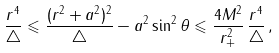<formula> <loc_0><loc_0><loc_500><loc_500>\frac { r ^ { 4 } } { \triangle } \leqslant \frac { ( r ^ { 2 } + a ^ { 2 } ) ^ { 2 } } { \triangle } - a ^ { 2 } \sin ^ { 2 } \theta \leqslant \frac { 4 M ^ { 2 } } { r _ { + } ^ { 2 } } \, \frac { r ^ { 4 } } { \triangle } \, , \,</formula> 